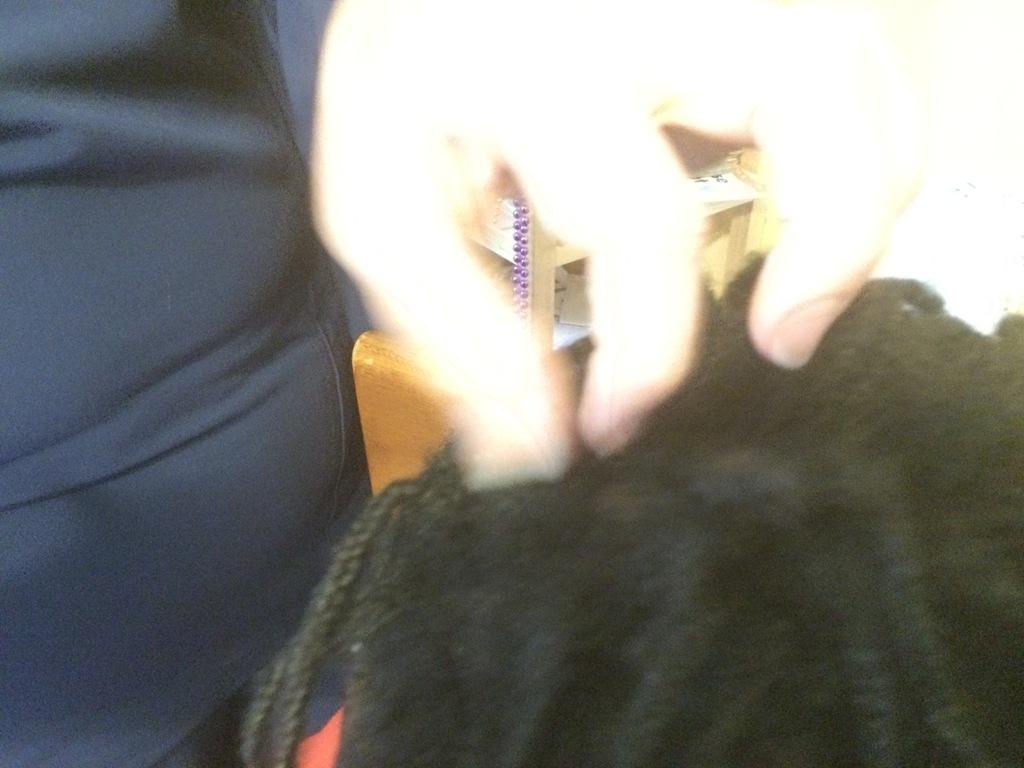Can you describe this image briefly? In this image on the left side there is one person who is standing. On the right side there is one man's head is visible, in the background there are some objects. 